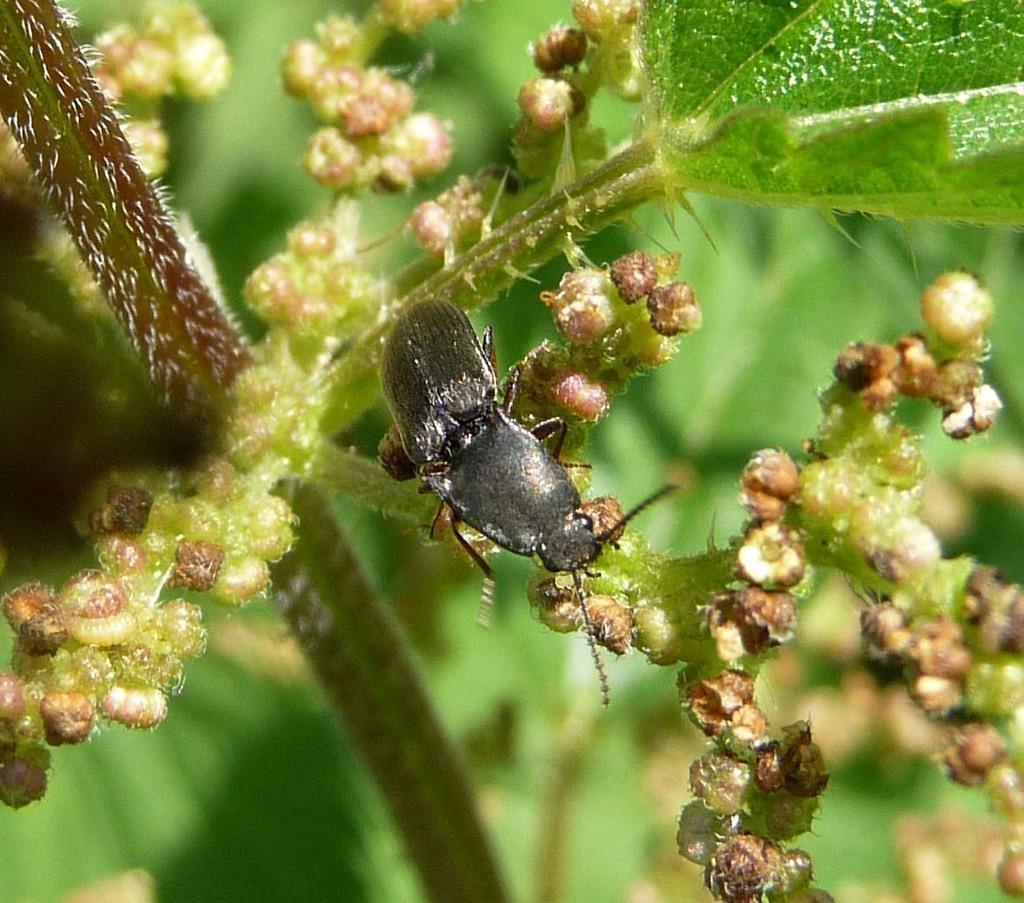Describe this image in one or two sentences. In this picture there is a dung beetle in the center of the image on the plant and the background area of the image is blur. 